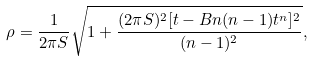<formula> <loc_0><loc_0><loc_500><loc_500>\rho = \frac { 1 } { 2 \pi S } \sqrt { 1 + \frac { ( 2 \pi S ) ^ { 2 } [ t - B n ( n - 1 ) t ^ { n } ] ^ { 2 } } { ( n - 1 ) ^ { 2 } } } ,</formula> 